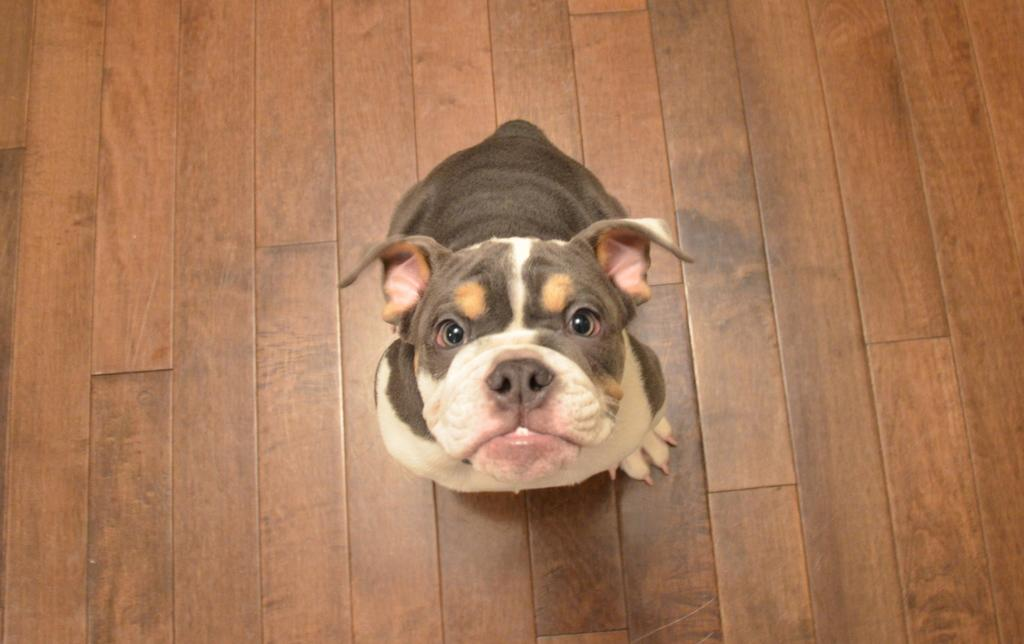What is the main subject in the center of the image? There is a bulldog in the center of the image. What type of surface is visible in the background of the image? There is a floor visible in the background of the image. What type of bottle is the bulldog holding in the image? There is no bottle present in the image; the bulldog is not holding anything. 